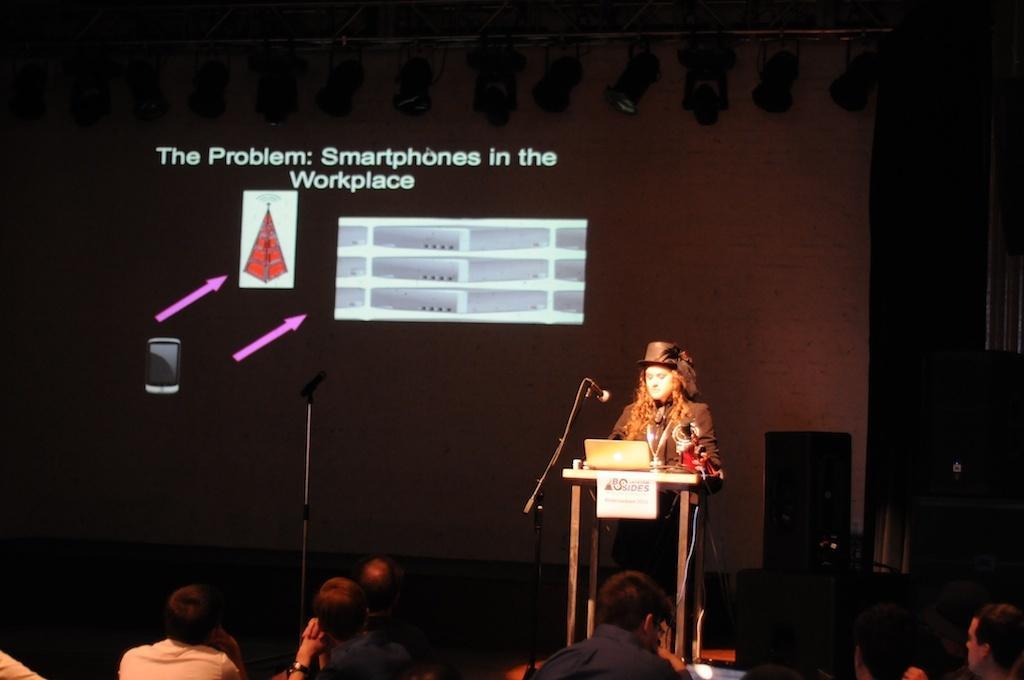Can you describe this image briefly? In this image I can see in the middle a woman is standing near the podium, she wore coat, hat in black color. At the bottom few people are looking at this image, there is a projected image in the middle of an image. 